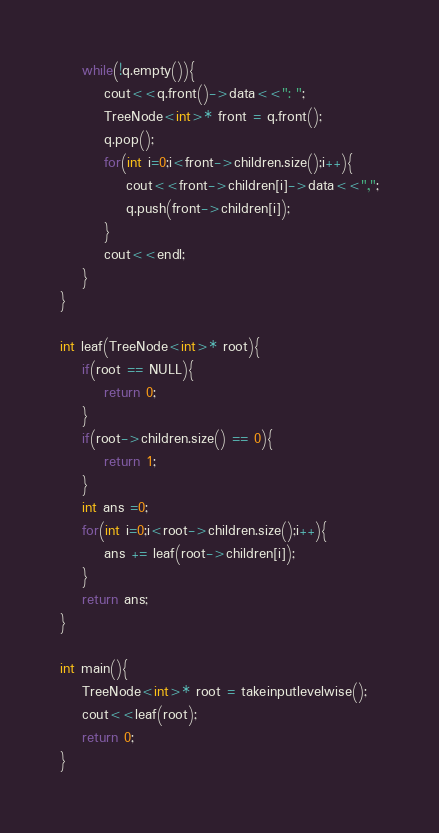<code> <loc_0><loc_0><loc_500><loc_500><_C++_>    while(!q.empty()){
        cout<<q.front()->data<<": ";
        TreeNode<int>* front = q.front();
        q.pop();
        for(int i=0;i<front->children.size();i++){
            cout<<front->children[i]->data<<",";
            q.push(front->children[i]);
        }
        cout<<endl;
    }
}

int leaf(TreeNode<int>* root){
    if(root == NULL){
        return 0;
    }
    if(root->children.size() == 0){
        return 1;
    }
    int ans =0;
    for(int i=0;i<root->children.size();i++){
        ans += leaf(root->children[i]);
    }
    return ans;
}

int main(){
    TreeNode<int>* root = takeinputlevelwise();
    cout<<leaf(root);
    return 0;
}</code> 